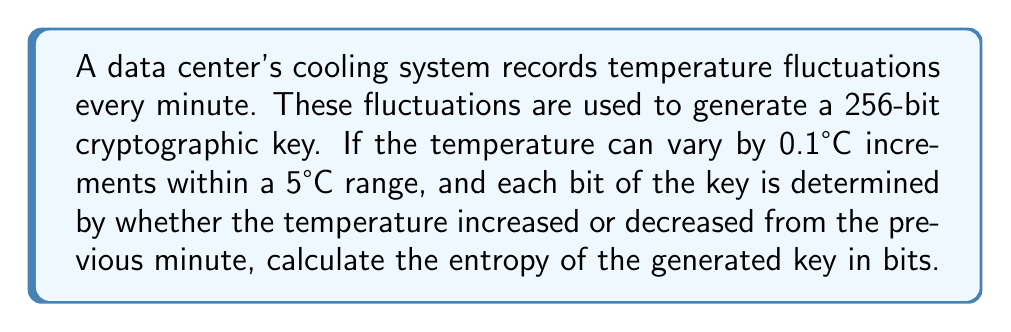Give your solution to this math problem. To calculate the entropy of the cryptographic key, we need to follow these steps:

1. Determine the number of possible states for each bit:
   There are 2 possible states for each bit (increase or decrease in temperature).

2. Calculate the probability of each state:
   As there are only 2 possible outcomes for each bit, the probability is:
   $p = \frac{1}{2} = 0.5$

3. Use the entropy formula for a binary system:
   The entropy (H) for a single bit is given by:
   $$H = -p \log_2(p) - (1-p) \log_2(1-p)$$
   
   Substituting $p = 0.5$:
   $$H = -0.5 \log_2(0.5) - 0.5 \log_2(0.5)$$
   $$H = -0.5 (-1) - 0.5 (-1) = 0.5 + 0.5 = 1 \text{ bit}$$

4. Calculate the total entropy for the 256-bit key:
   As each bit contributes 1 bit of entropy, and there are 256 bits in total:
   $$\text{Total Entropy} = 256 \times 1 = 256 \text{ bits}$$

Note: The actual temperature range (5°C) and increment (0.1°C) don't affect the entropy calculation in this case, as we're only concerned with whether the temperature increased or decreased, not the magnitude of the change.
Answer: 256 bits 